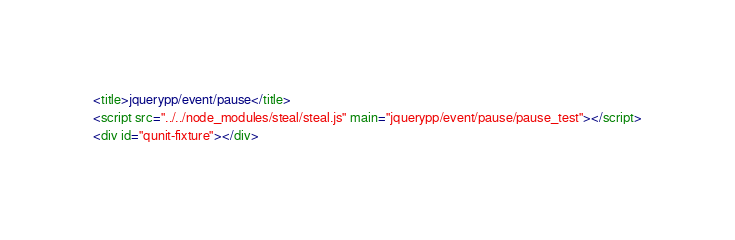Convert code to text. <code><loc_0><loc_0><loc_500><loc_500><_HTML_><title>jquerypp/event/pause</title>
<script src="../../node_modules/steal/steal.js" main="jquerypp/event/pause/pause_test"></script>
<div id="qunit-fixture"></div>
</code> 